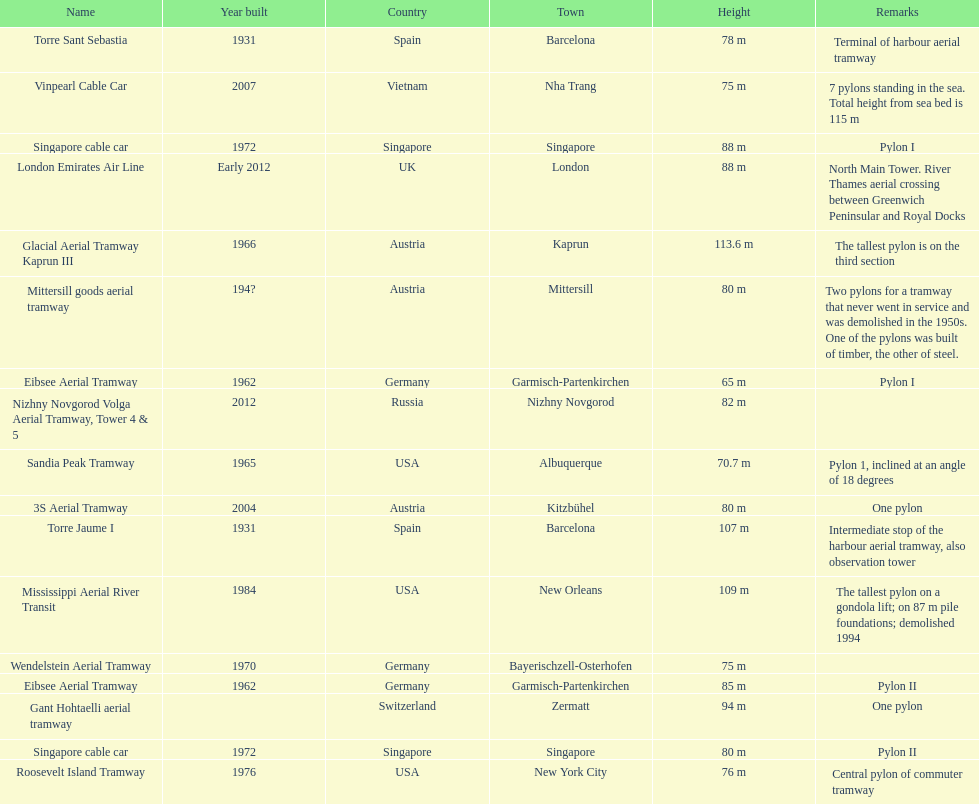Could you parse the entire table? {'header': ['Name', 'Year built', 'Country', 'Town', 'Height', 'Remarks'], 'rows': [['Torre Sant Sebastia', '1931', 'Spain', 'Barcelona', '78 m', 'Terminal of harbour aerial tramway'], ['Vinpearl Cable Car', '2007', 'Vietnam', 'Nha Trang', '75 m', '7 pylons standing in the sea. Total height from sea bed is 115 m'], ['Singapore cable car', '1972', 'Singapore', 'Singapore', '88 m', 'Pylon I'], ['London Emirates Air Line', 'Early 2012', 'UK', 'London', '88 m', 'North Main Tower. River Thames aerial crossing between Greenwich Peninsular and Royal Docks'], ['Glacial Aerial Tramway Kaprun III', '1966', 'Austria', 'Kaprun', '113.6 m', 'The tallest pylon is on the third section'], ['Mittersill goods aerial tramway', '194?', 'Austria', 'Mittersill', '80 m', 'Two pylons for a tramway that never went in service and was demolished in the 1950s. One of the pylons was built of timber, the other of steel.'], ['Eibsee Aerial Tramway', '1962', 'Germany', 'Garmisch-Partenkirchen', '65 m', 'Pylon I'], ['Nizhny Novgorod Volga Aerial Tramway, Tower 4 & 5', '2012', 'Russia', 'Nizhny Novgorod', '82 m', ''], ['Sandia Peak Tramway', '1965', 'USA', 'Albuquerque', '70.7 m', 'Pylon 1, inclined at an angle of 18 degrees'], ['3S Aerial Tramway', '2004', 'Austria', 'Kitzbühel', '80 m', 'One pylon'], ['Torre Jaume I', '1931', 'Spain', 'Barcelona', '107 m', 'Intermediate stop of the harbour aerial tramway, also observation tower'], ['Mississippi Aerial River Transit', '1984', 'USA', 'New Orleans', '109 m', 'The tallest pylon on a gondola lift; on 87 m pile foundations; demolished 1994'], ['Wendelstein Aerial Tramway', '1970', 'Germany', 'Bayerischzell-Osterhofen', '75 m', ''], ['Eibsee Aerial Tramway', '1962', 'Germany', 'Garmisch-Partenkirchen', '85 m', 'Pylon II'], ['Gant Hohtaelli aerial tramway', '', 'Switzerland', 'Zermatt', '94 m', 'One pylon'], ['Singapore cable car', '1972', 'Singapore', 'Singapore', '80 m', 'Pylon II'], ['Roosevelt Island Tramway', '1976', 'USA', 'New York City', '76 m', 'Central pylon of commuter tramway']]} The london emirates air line pylon has the same height as which pylon? Singapore cable car. 